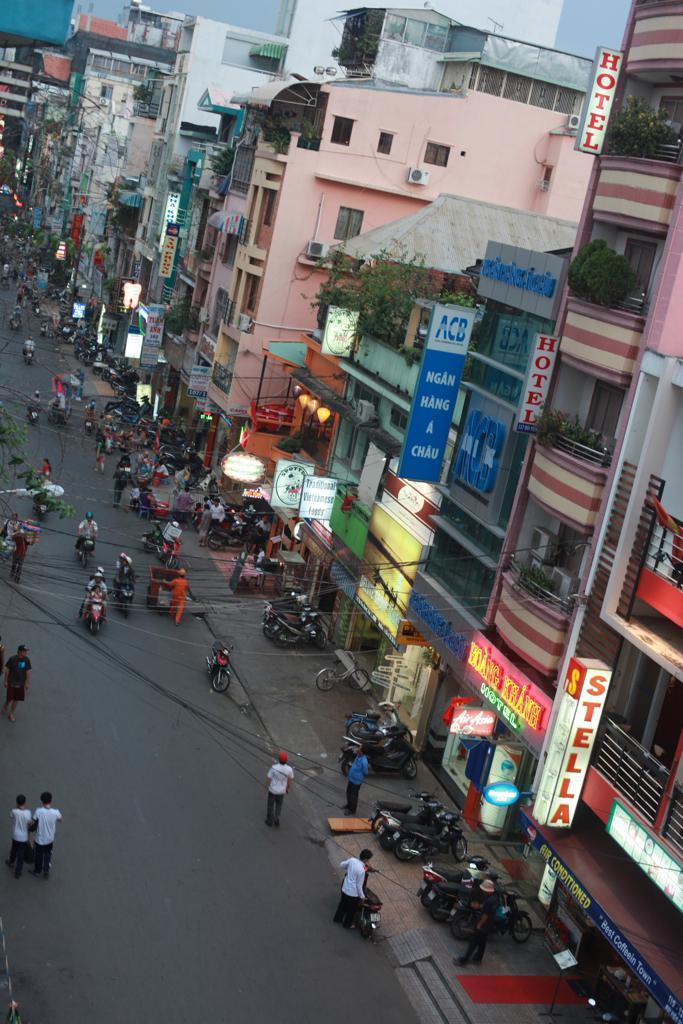What type of structures can be seen in the image? There are buildings in the image. What objects are present in the image that might be used for displaying information or advertisements? There are boards in the image. What type of vegetation is visible in the image? There are plants in the image. What can be seen providing illumination in the image? There are lights in the image. What mode of transportation is visible in the image? There are bikes in the image. Are there any human figures present in the image? Yes, there are people in the image. What type of pathway is visible in the image? There is a road in the image. Can you tell me how many cans are present in the image? There is no mention of cans in the provided facts, so it cannot be determined if any are present in the image. What type of line is visible in the image? There is no specific line mentioned in the provided facts, so it cannot be determined if any are present in the image. 